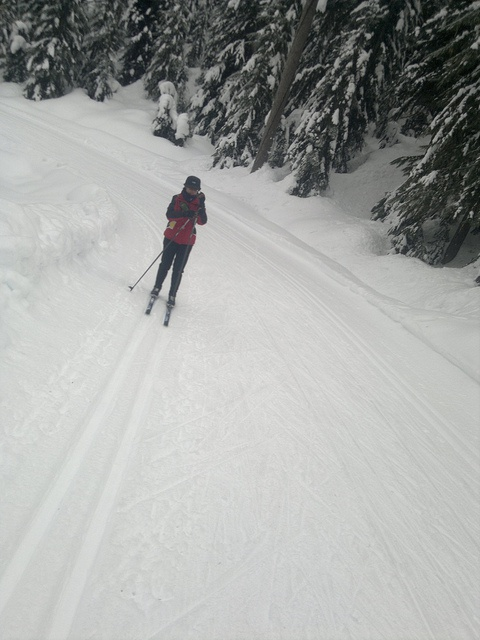Describe the objects in this image and their specific colors. I can see people in black, gray, brown, and darkblue tones and skis in black, gray, and darkgray tones in this image. 